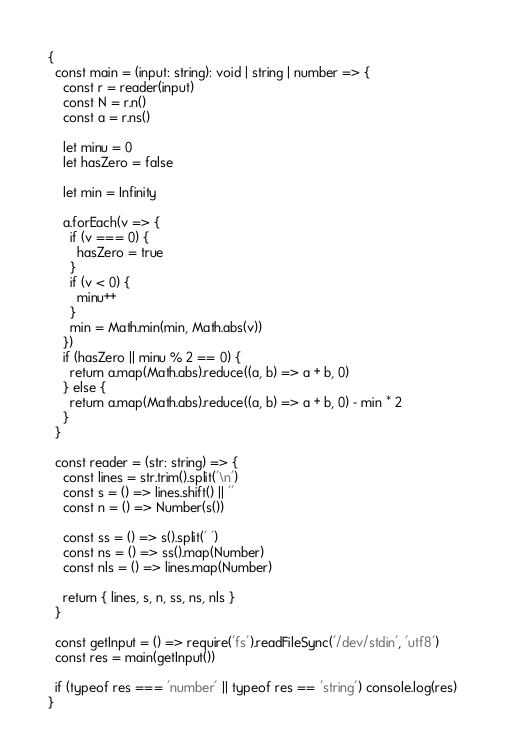Convert code to text. <code><loc_0><loc_0><loc_500><loc_500><_TypeScript_>{
  const main = (input: string): void | string | number => {
    const r = reader(input)
    const N = r.n()
    const a = r.ns()

    let minu = 0
    let hasZero = false

    let min = Infinity

    a.forEach(v => {
      if (v === 0) {
        hasZero = true
      }
      if (v < 0) {
        minu++
      }
      min = Math.min(min, Math.abs(v))
    })
    if (hasZero || minu % 2 == 0) {
      return a.map(Math.abs).reduce((a, b) => a + b, 0)
    } else {
      return a.map(Math.abs).reduce((a, b) => a + b, 0) - min * 2
    }
  }

  const reader = (str: string) => {
    const lines = str.trim().split('\n')
    const s = () => lines.shift() || ''
    const n = () => Number(s())

    const ss = () => s().split(' ')
    const ns = () => ss().map(Number)
    const nls = () => lines.map(Number)

    return { lines, s, n, ss, ns, nls }
  }

  const getInput = () => require('fs').readFileSync('/dev/stdin', 'utf8')
  const res = main(getInput())

  if (typeof res === 'number' || typeof res == 'string') console.log(res)
}
</code> 